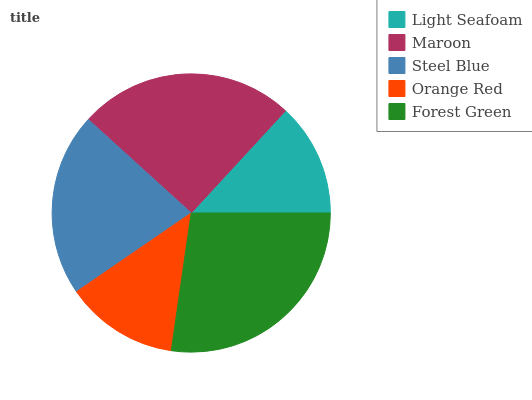Is Orange Red the minimum?
Answer yes or no. Yes. Is Forest Green the maximum?
Answer yes or no. Yes. Is Maroon the minimum?
Answer yes or no. No. Is Maroon the maximum?
Answer yes or no. No. Is Maroon greater than Light Seafoam?
Answer yes or no. Yes. Is Light Seafoam less than Maroon?
Answer yes or no. Yes. Is Light Seafoam greater than Maroon?
Answer yes or no. No. Is Maroon less than Light Seafoam?
Answer yes or no. No. Is Steel Blue the high median?
Answer yes or no. Yes. Is Steel Blue the low median?
Answer yes or no. Yes. Is Light Seafoam the high median?
Answer yes or no. No. Is Forest Green the low median?
Answer yes or no. No. 